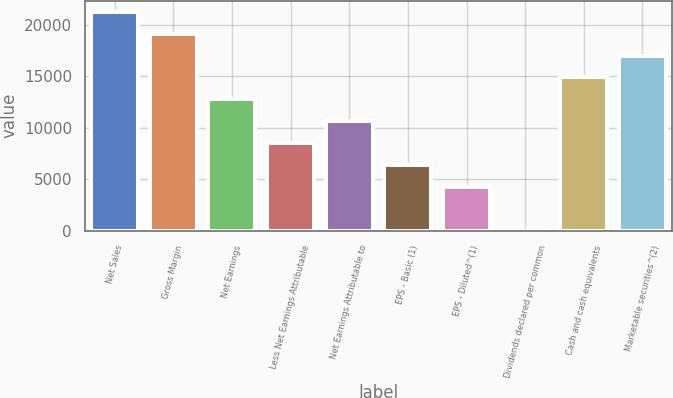Convert chart to OTSL. <chart><loc_0><loc_0><loc_500><loc_500><bar_chart><fcel>Net Sales<fcel>Gross Margin<fcel>Net Earnings<fcel>Less Net Earnings Attributable<fcel>Net Earnings Attributable to<fcel>EPS - Basic (1)<fcel>EPS - Diluted^(1)<fcel>Dividends declared per common<fcel>Cash and cash equivalents<fcel>Marketable securities^(2)<nl><fcel>21244<fcel>19119.8<fcel>12747<fcel>8498.41<fcel>10622.7<fcel>6374.14<fcel>4249.87<fcel>1.33<fcel>14871.2<fcel>16995.5<nl></chart> 